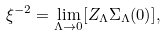Convert formula to latex. <formula><loc_0><loc_0><loc_500><loc_500>\xi ^ { - 2 } = \lim _ { \Lambda \to 0 } [ Z _ { \Lambda } \Sigma _ { \Lambda } ( 0 ) ] ,</formula> 